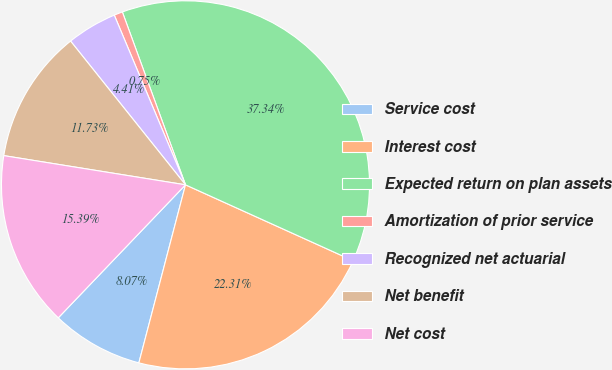Convert chart. <chart><loc_0><loc_0><loc_500><loc_500><pie_chart><fcel>Service cost<fcel>Interest cost<fcel>Expected return on plan assets<fcel>Amortization of prior service<fcel>Recognized net actuarial<fcel>Net benefit<fcel>Net cost<nl><fcel>8.07%<fcel>22.31%<fcel>37.34%<fcel>0.75%<fcel>4.41%<fcel>11.73%<fcel>15.39%<nl></chart> 